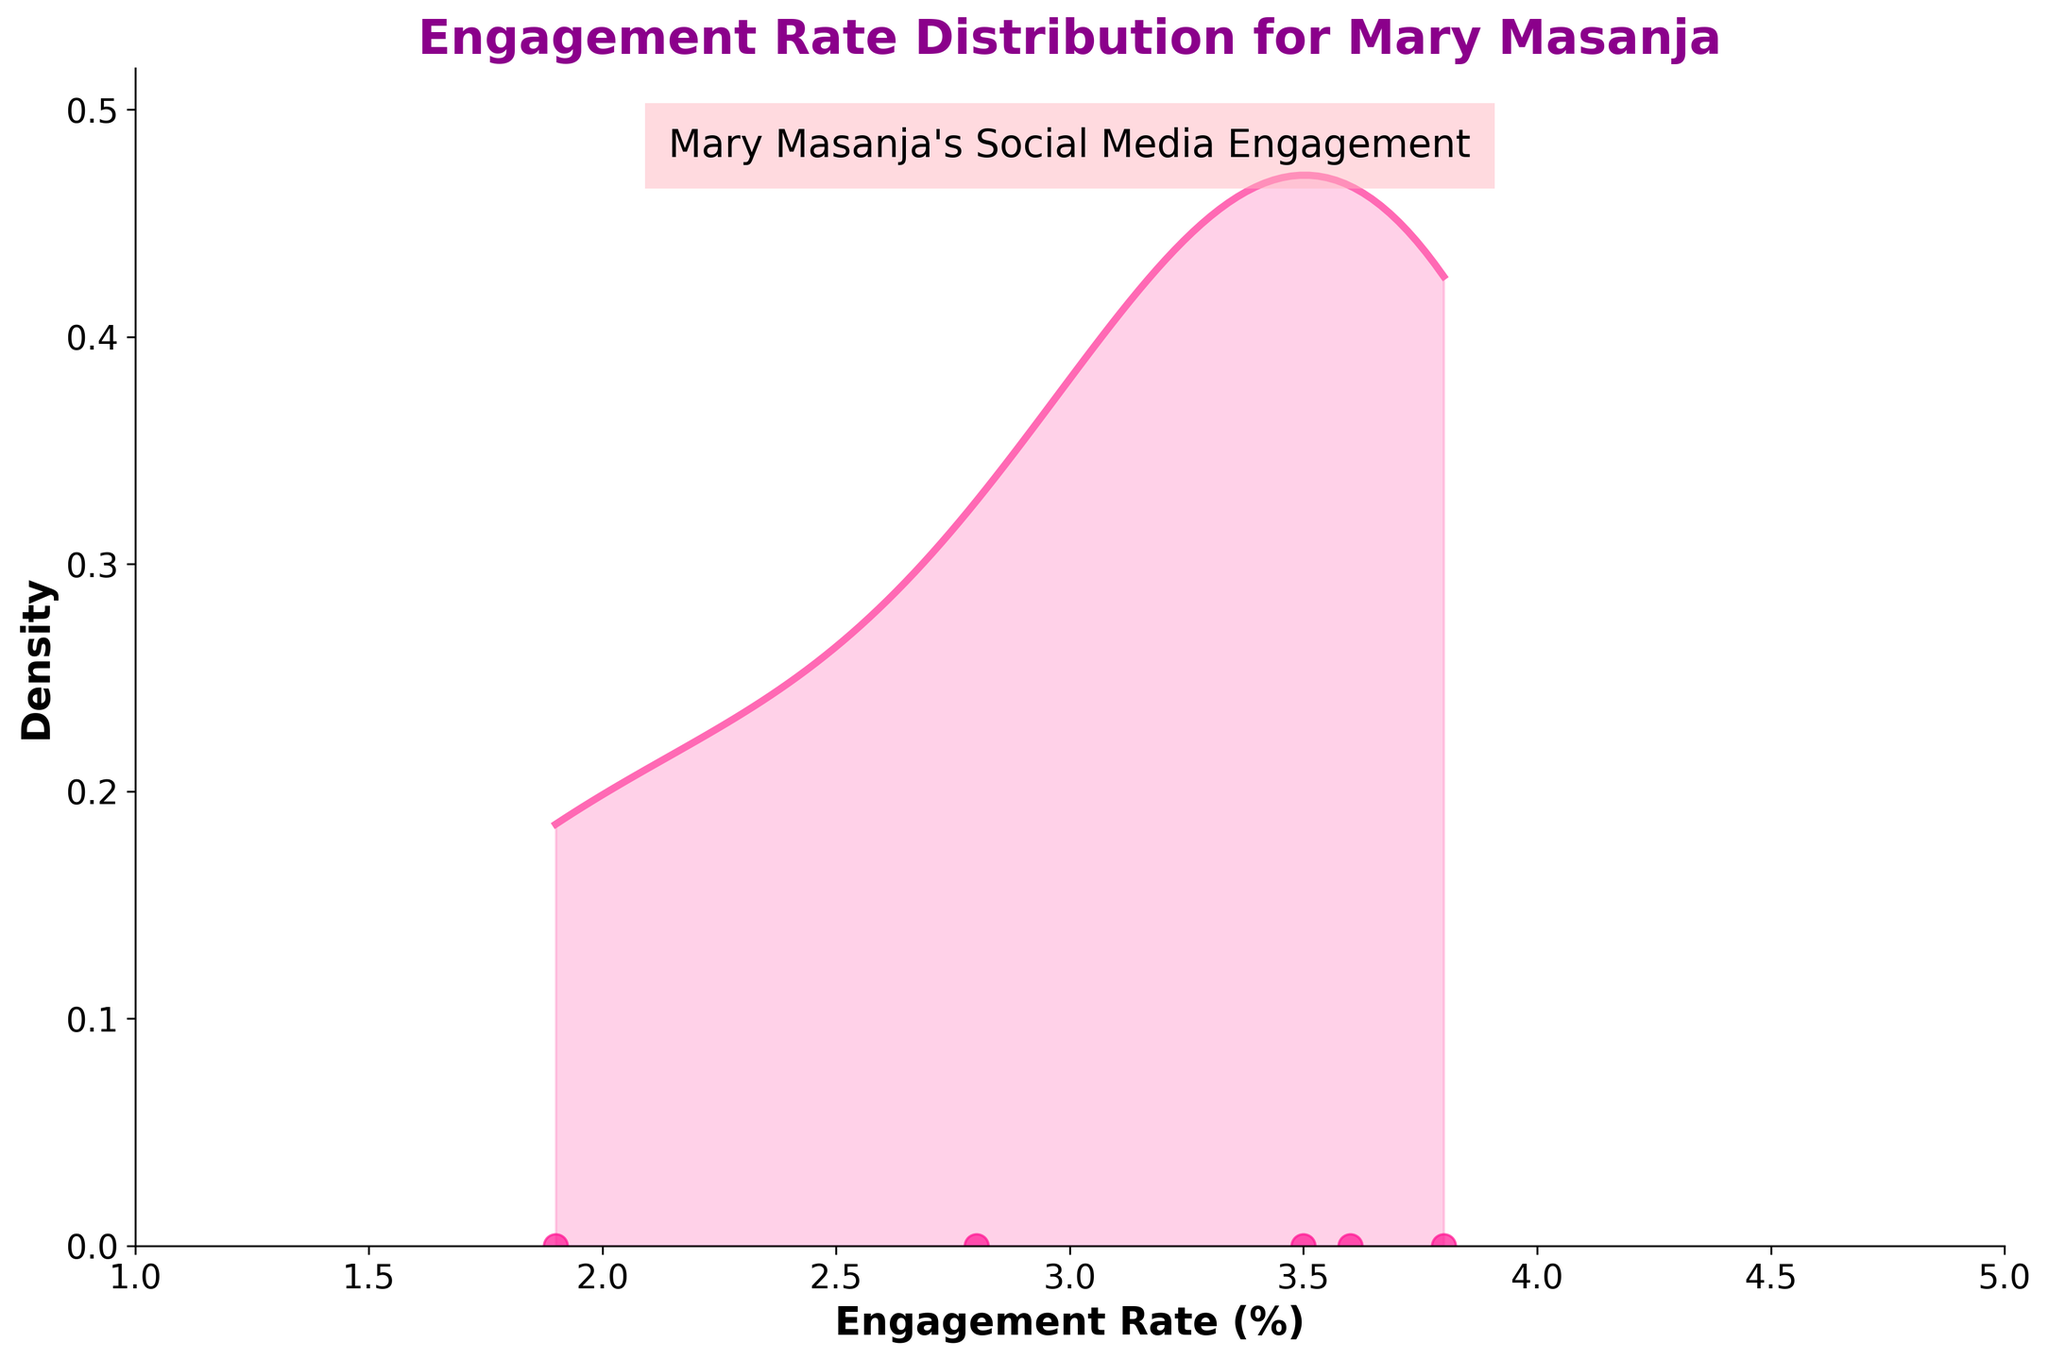What is the title of the figure? The title of the figure is the text displayed at the top, which provides an overview of what the figure represents.
Answer: Engagement Rate Distribution for Mary Masanja What does the x-axis represent? The x-axis is labeled as "Engagement Rate (%)", indicating it shows the percentage engagement rates.
Answer: Engagement Rate (%) How many engagement rate data points are there for Mary Masanja? The data points are represented by scattered markers on the density plot. By counting these markers, we can determine the number of engagement rate data points.
Answer: 4 data points What is the color used for the density curve? The density curve is drawn in a distinctive color, making it easy to identify.
Answer: Pink What is the range of engagement rates shown in the plot? The range can be determined by looking at the minimum and maximum values on the x-axis.
Answer: 1% to 5% At which engagement rate value does the density peak occur for Mary Masanja? The peak in the density curve is where the density value is the highest. By locating this peak on the x-axis, we can determine the corresponding engagement rate value.
Answer: Around 3.6% What's the difference between the highest and lowest engagement rates for Mary Masanja? The highest engagement rate is the maximum x-axis value where a scatter point exists, and the lowest is the minimum x-axis value with a scatter point. Subtract the lowest from the highest to find the difference.
Answer: 3.6% (3.6 - 1.9 = 1.7) Which engagement rate is most frequent for Mary Masanja, based on the scatter plot? To find the most frequent engagement rate, we look for the engagement rate value with the most scatter points closely overlapping.
Answer: 3.6% How does Mary Masanja's engagement rate distribution appear in terms of spread? Analyzing the spread entails looking at the width of the density plot. A wider spread indicates more variation, while a narrower spread indicates less variation.
Answer: Quite spread out with variation between 1.9% and 3.6% What is the highest density value on the y-axis? The highest density value can be observed directly on the y-axis at the peak of the density plot.
Answer: Approximately 1.1 Which platform could potentially have the highest engagement rate for Mary Masanja based on the data points shown in the plot? By observing the scatter plot, identify the engagement rate value and compare it to the platforms (Facebook, Twitter, Instagram).
Answer: Instagram 